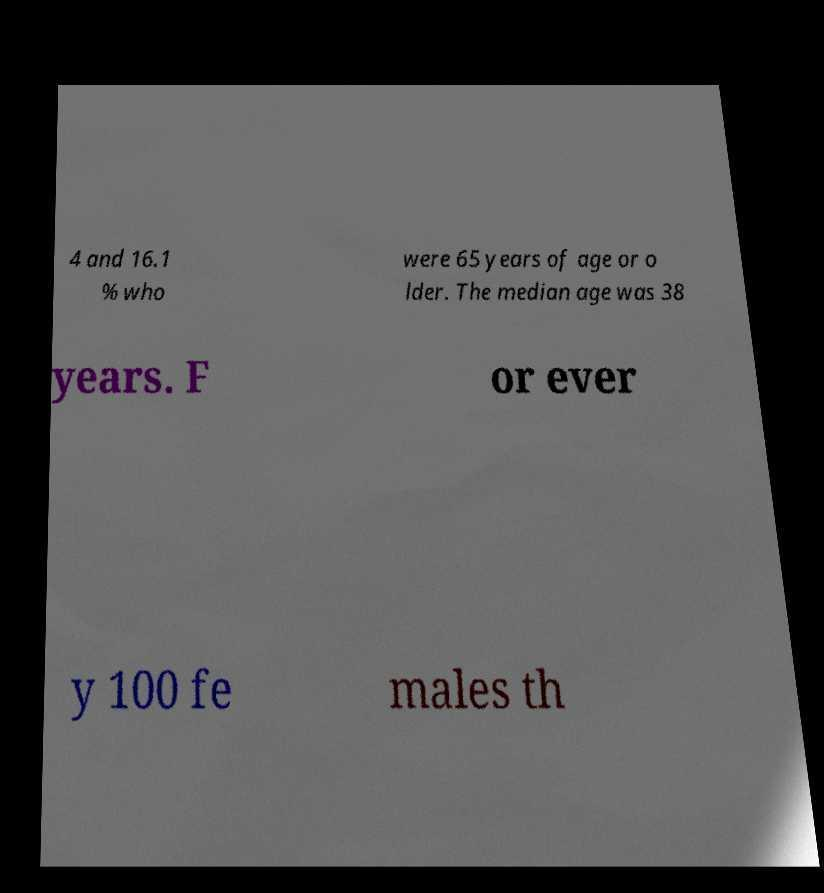For documentation purposes, I need the text within this image transcribed. Could you provide that? 4 and 16.1 % who were 65 years of age or o lder. The median age was 38 years. F or ever y 100 fe males th 